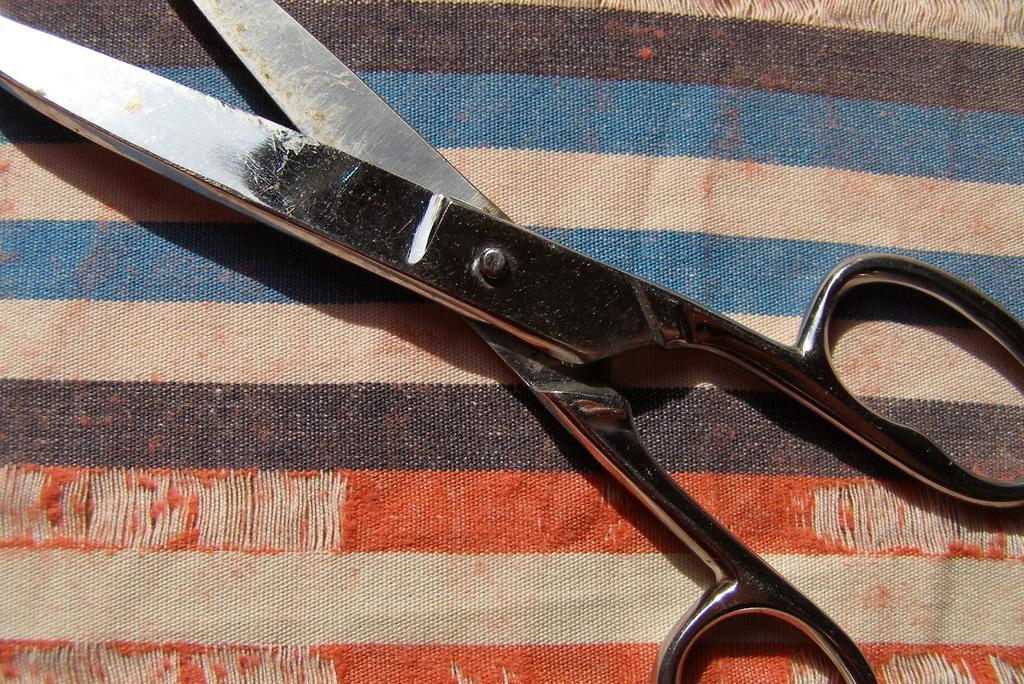How would you summarize this image in a sentence or two? In this image I can see a colourful cloth and on it I can see an iron scissor. 